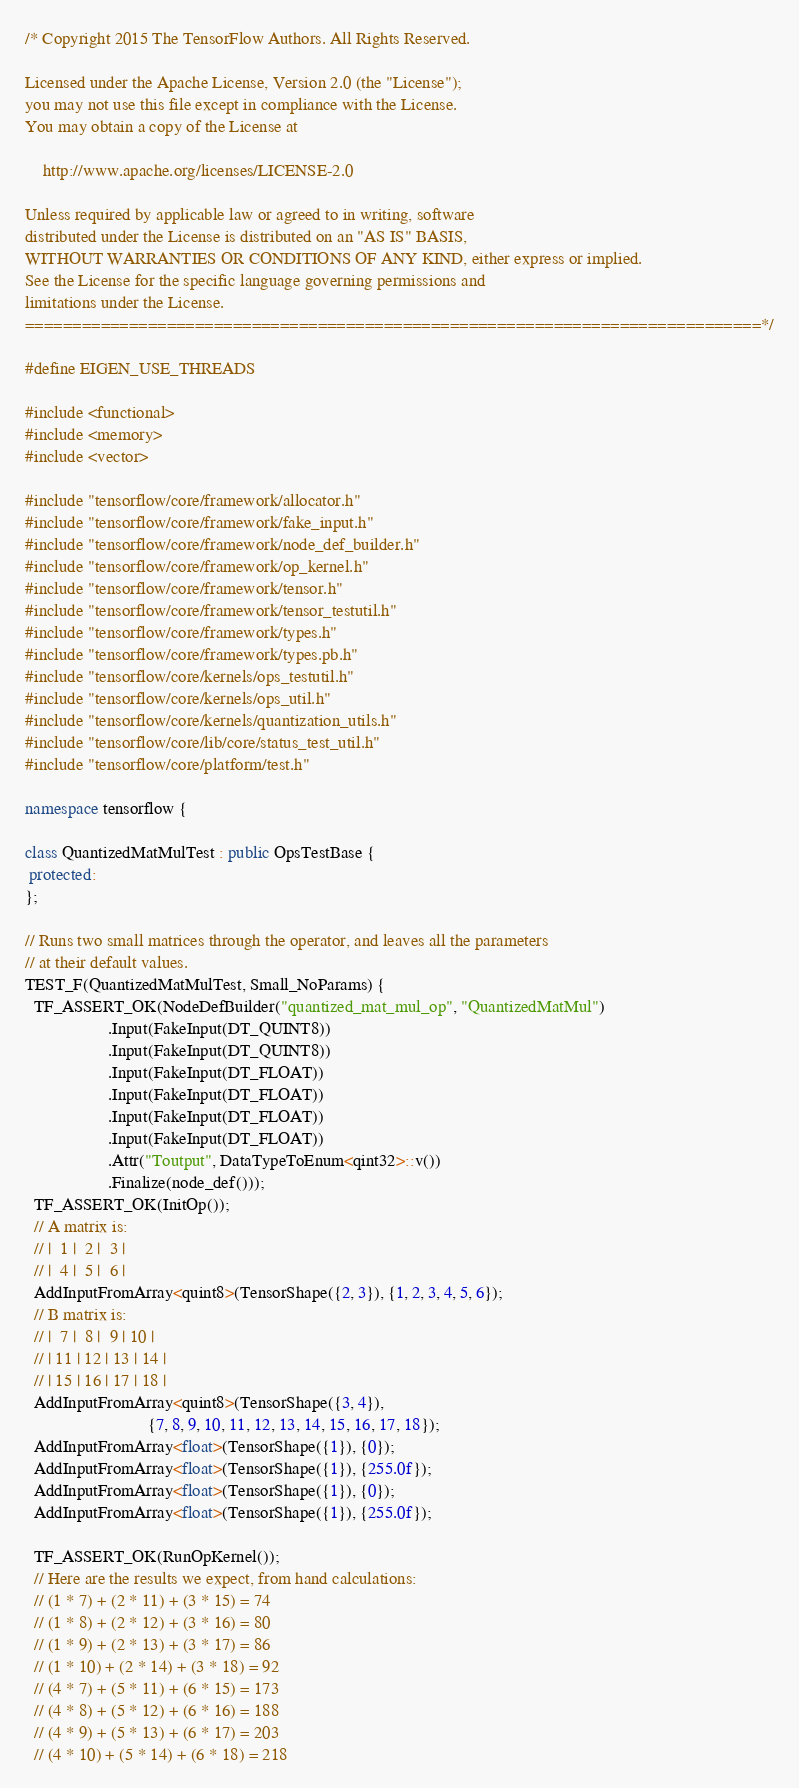<code> <loc_0><loc_0><loc_500><loc_500><_C++_>/* Copyright 2015 The TensorFlow Authors. All Rights Reserved.

Licensed under the Apache License, Version 2.0 (the "License");
you may not use this file except in compliance with the License.
You may obtain a copy of the License at

    http://www.apache.org/licenses/LICENSE-2.0

Unless required by applicable law or agreed to in writing, software
distributed under the License is distributed on an "AS IS" BASIS,
WITHOUT WARRANTIES OR CONDITIONS OF ANY KIND, either express or implied.
See the License for the specific language governing permissions and
limitations under the License.
==============================================================================*/

#define EIGEN_USE_THREADS

#include <functional>
#include <memory>
#include <vector>

#include "tensorflow/core/framework/allocator.h"
#include "tensorflow/core/framework/fake_input.h"
#include "tensorflow/core/framework/node_def_builder.h"
#include "tensorflow/core/framework/op_kernel.h"
#include "tensorflow/core/framework/tensor.h"
#include "tensorflow/core/framework/tensor_testutil.h"
#include "tensorflow/core/framework/types.h"
#include "tensorflow/core/framework/types.pb.h"
#include "tensorflow/core/kernels/ops_testutil.h"
#include "tensorflow/core/kernels/ops_util.h"
#include "tensorflow/core/kernels/quantization_utils.h"
#include "tensorflow/core/lib/core/status_test_util.h"
#include "tensorflow/core/platform/test.h"

namespace tensorflow {

class QuantizedMatMulTest : public OpsTestBase {
 protected:
};

// Runs two small matrices through the operator, and leaves all the parameters
// at their default values.
TEST_F(QuantizedMatMulTest, Small_NoParams) {
  TF_ASSERT_OK(NodeDefBuilder("quantized_mat_mul_op", "QuantizedMatMul")
                   .Input(FakeInput(DT_QUINT8))
                   .Input(FakeInput(DT_QUINT8))
                   .Input(FakeInput(DT_FLOAT))
                   .Input(FakeInput(DT_FLOAT))
                   .Input(FakeInput(DT_FLOAT))
                   .Input(FakeInput(DT_FLOAT))
                   .Attr("Toutput", DataTypeToEnum<qint32>::v())
                   .Finalize(node_def()));
  TF_ASSERT_OK(InitOp());
  // A matrix is:
  // |  1 |  2 |  3 |
  // |  4 |  5 |  6 |
  AddInputFromArray<quint8>(TensorShape({2, 3}), {1, 2, 3, 4, 5, 6});
  // B matrix is:
  // |  7 |  8 |  9 | 10 |
  // | 11 | 12 | 13 | 14 |
  // | 15 | 16 | 17 | 18 |
  AddInputFromArray<quint8>(TensorShape({3, 4}),
                            {7, 8, 9, 10, 11, 12, 13, 14, 15, 16, 17, 18});
  AddInputFromArray<float>(TensorShape({1}), {0});
  AddInputFromArray<float>(TensorShape({1}), {255.0f});
  AddInputFromArray<float>(TensorShape({1}), {0});
  AddInputFromArray<float>(TensorShape({1}), {255.0f});

  TF_ASSERT_OK(RunOpKernel());
  // Here are the results we expect, from hand calculations:
  // (1 * 7) + (2 * 11) + (3 * 15) = 74
  // (1 * 8) + (2 * 12) + (3 * 16) = 80
  // (1 * 9) + (2 * 13) + (3 * 17) = 86
  // (1 * 10) + (2 * 14) + (3 * 18) = 92
  // (4 * 7) + (5 * 11) + (6 * 15) = 173
  // (4 * 8) + (5 * 12) + (6 * 16) = 188
  // (4 * 9) + (5 * 13) + (6 * 17) = 203
  // (4 * 10) + (5 * 14) + (6 * 18) = 218</code> 